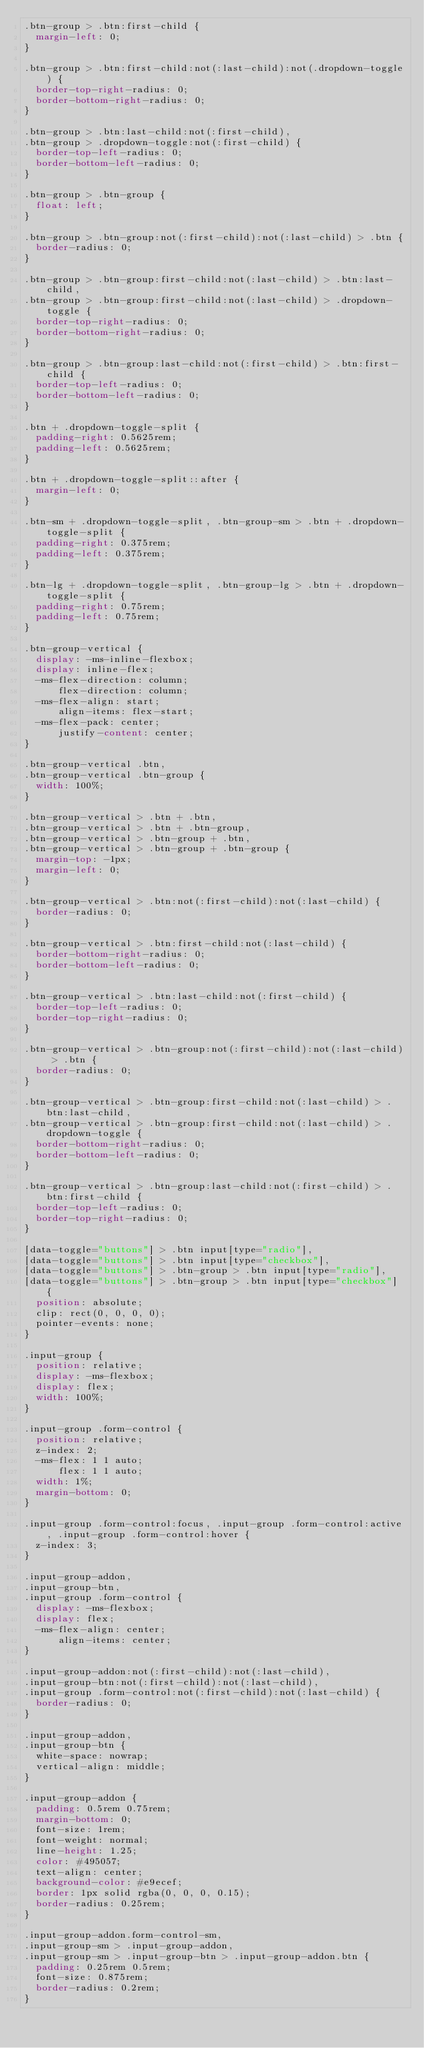<code> <loc_0><loc_0><loc_500><loc_500><_CSS_>.btn-group > .btn:first-child {
  margin-left: 0;
}

.btn-group > .btn:first-child:not(:last-child):not(.dropdown-toggle) {
  border-top-right-radius: 0;
  border-bottom-right-radius: 0;
}

.btn-group > .btn:last-child:not(:first-child),
.btn-group > .dropdown-toggle:not(:first-child) {
  border-top-left-radius: 0;
  border-bottom-left-radius: 0;
}

.btn-group > .btn-group {
  float: left;
}

.btn-group > .btn-group:not(:first-child):not(:last-child) > .btn {
  border-radius: 0;
}

.btn-group > .btn-group:first-child:not(:last-child) > .btn:last-child,
.btn-group > .btn-group:first-child:not(:last-child) > .dropdown-toggle {
  border-top-right-radius: 0;
  border-bottom-right-radius: 0;
}

.btn-group > .btn-group:last-child:not(:first-child) > .btn:first-child {
  border-top-left-radius: 0;
  border-bottom-left-radius: 0;
}

.btn + .dropdown-toggle-split {
  padding-right: 0.5625rem;
  padding-left: 0.5625rem;
}

.btn + .dropdown-toggle-split::after {
  margin-left: 0;
}

.btn-sm + .dropdown-toggle-split, .btn-group-sm > .btn + .dropdown-toggle-split {
  padding-right: 0.375rem;
  padding-left: 0.375rem;
}

.btn-lg + .dropdown-toggle-split, .btn-group-lg > .btn + .dropdown-toggle-split {
  padding-right: 0.75rem;
  padding-left: 0.75rem;
}

.btn-group-vertical {
  display: -ms-inline-flexbox;
  display: inline-flex;
  -ms-flex-direction: column;
      flex-direction: column;
  -ms-flex-align: start;
      align-items: flex-start;
  -ms-flex-pack: center;
      justify-content: center;
}

.btn-group-vertical .btn,
.btn-group-vertical .btn-group {
  width: 100%;
}

.btn-group-vertical > .btn + .btn,
.btn-group-vertical > .btn + .btn-group,
.btn-group-vertical > .btn-group + .btn,
.btn-group-vertical > .btn-group + .btn-group {
  margin-top: -1px;
  margin-left: 0;
}

.btn-group-vertical > .btn:not(:first-child):not(:last-child) {
  border-radius: 0;
}

.btn-group-vertical > .btn:first-child:not(:last-child) {
  border-bottom-right-radius: 0;
  border-bottom-left-radius: 0;
}

.btn-group-vertical > .btn:last-child:not(:first-child) {
  border-top-left-radius: 0;
  border-top-right-radius: 0;
}

.btn-group-vertical > .btn-group:not(:first-child):not(:last-child) > .btn {
  border-radius: 0;
}

.btn-group-vertical > .btn-group:first-child:not(:last-child) > .btn:last-child,
.btn-group-vertical > .btn-group:first-child:not(:last-child) > .dropdown-toggle {
  border-bottom-right-radius: 0;
  border-bottom-left-radius: 0;
}

.btn-group-vertical > .btn-group:last-child:not(:first-child) > .btn:first-child {
  border-top-left-radius: 0;
  border-top-right-radius: 0;
}

[data-toggle="buttons"] > .btn input[type="radio"],
[data-toggle="buttons"] > .btn input[type="checkbox"],
[data-toggle="buttons"] > .btn-group > .btn input[type="radio"],
[data-toggle="buttons"] > .btn-group > .btn input[type="checkbox"] {
  position: absolute;
  clip: rect(0, 0, 0, 0);
  pointer-events: none;
}

.input-group {
  position: relative;
  display: -ms-flexbox;
  display: flex;
  width: 100%;
}

.input-group .form-control {
  position: relative;
  z-index: 2;
  -ms-flex: 1 1 auto;
      flex: 1 1 auto;
  width: 1%;
  margin-bottom: 0;
}

.input-group .form-control:focus, .input-group .form-control:active, .input-group .form-control:hover {
  z-index: 3;
}

.input-group-addon,
.input-group-btn,
.input-group .form-control {
  display: -ms-flexbox;
  display: flex;
  -ms-flex-align: center;
      align-items: center;
}

.input-group-addon:not(:first-child):not(:last-child),
.input-group-btn:not(:first-child):not(:last-child),
.input-group .form-control:not(:first-child):not(:last-child) {
  border-radius: 0;
}

.input-group-addon,
.input-group-btn {
  white-space: nowrap;
  vertical-align: middle;
}

.input-group-addon {
  padding: 0.5rem 0.75rem;
  margin-bottom: 0;
  font-size: 1rem;
  font-weight: normal;
  line-height: 1.25;
  color: #495057;
  text-align: center;
  background-color: #e9ecef;
  border: 1px solid rgba(0, 0, 0, 0.15);
  border-radius: 0.25rem;
}

.input-group-addon.form-control-sm,
.input-group-sm > .input-group-addon,
.input-group-sm > .input-group-btn > .input-group-addon.btn {
  padding: 0.25rem 0.5rem;
  font-size: 0.875rem;
  border-radius: 0.2rem;
}
</code> 